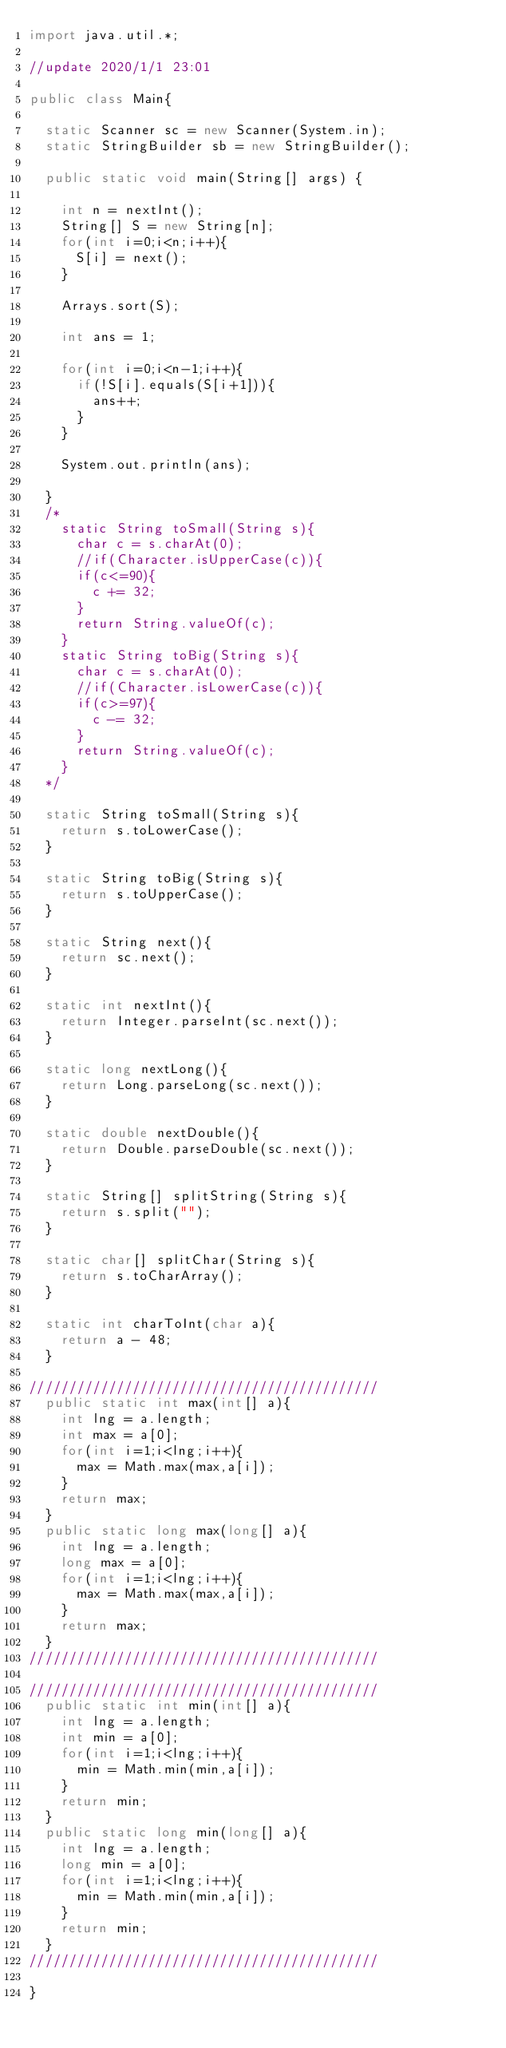<code> <loc_0><loc_0><loc_500><loc_500><_Java_>import java.util.*;

//update 2020/1/1 23:01

public class Main{

  static Scanner sc = new Scanner(System.in);
  static StringBuilder sb = new StringBuilder();

  public static void main(String[] args) {

    int n = nextInt();
    String[] S = new String[n];
    for(int i=0;i<n;i++){
      S[i] = next();
    }

    Arrays.sort(S);

    int ans = 1;

    for(int i=0;i<n-1;i++){
      if(!S[i].equals(S[i+1])){
        ans++;
      }
    }

    System.out.println(ans);

  }
  /*
    static String toSmall(String s){
      char c = s.charAt(0);
      //if(Character.isUpperCase(c)){
      if(c<=90){
        c += 32;
      }
      return String.valueOf(c);
    }
    static String toBig(String s){
      char c = s.charAt(0);
      //if(Character.isLowerCase(c)){
      if(c>=97){
        c -= 32;
      }
      return String.valueOf(c);
    }
  */

  static String toSmall(String s){
    return s.toLowerCase();
  }

  static String toBig(String s){
    return s.toUpperCase();
  }

  static String next(){
    return sc.next();
  }

  static int nextInt(){
    return Integer.parseInt(sc.next());
  }

  static long nextLong(){
    return Long.parseLong(sc.next());
  }

  static double nextDouble(){
    return Double.parseDouble(sc.next());
  }

  static String[] splitString(String s){
    return s.split("");
  }

  static char[] splitChar(String s){
    return s.toCharArray();
  }

  static int charToInt(char a){
    return a - 48;
  }

////////////////////////////////////////////
  public static int max(int[] a){
    int lng = a.length;
    int max = a[0];
    for(int i=1;i<lng;i++){
      max = Math.max(max,a[i]);
    }
    return max;
  }
  public static long max(long[] a){
    int lng = a.length;
    long max = a[0];
    for(int i=1;i<lng;i++){
      max = Math.max(max,a[i]);
    }
    return max;
  }
////////////////////////////////////////////

////////////////////////////////////////////
  public static int min(int[] a){
    int lng = a.length;
    int min = a[0];
    for(int i=1;i<lng;i++){
      min = Math.min(min,a[i]);
    }
    return min;
  }
  public static long min(long[] a){
    int lng = a.length;
    long min = a[0];
    for(int i=1;i<lng;i++){
      min = Math.min(min,a[i]);
    }
    return min;
  }
////////////////////////////////////////////

}
</code> 